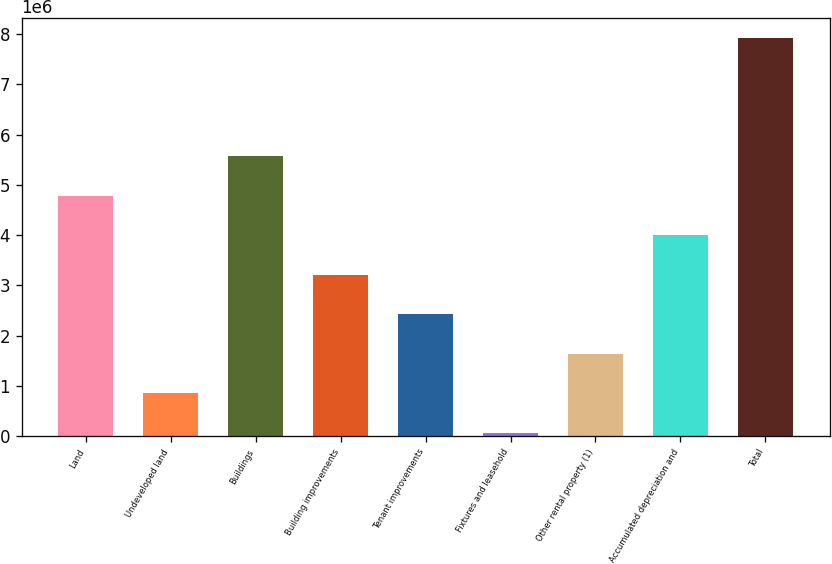Convert chart. <chart><loc_0><loc_0><loc_500><loc_500><bar_chart><fcel>Land<fcel>Undeveloped land<fcel>Buildings<fcel>Building improvements<fcel>Tenant improvements<fcel>Fixtures and leasehold<fcel>Other rental property (1)<fcel>Accumulated depreciation and<fcel>Total<nl><fcel>4.78274e+06<fcel>848059<fcel>5.56968e+06<fcel>3.20887e+06<fcel>2.42193e+06<fcel>61122<fcel>1.635e+06<fcel>3.99581e+06<fcel>7.93049e+06<nl></chart> 